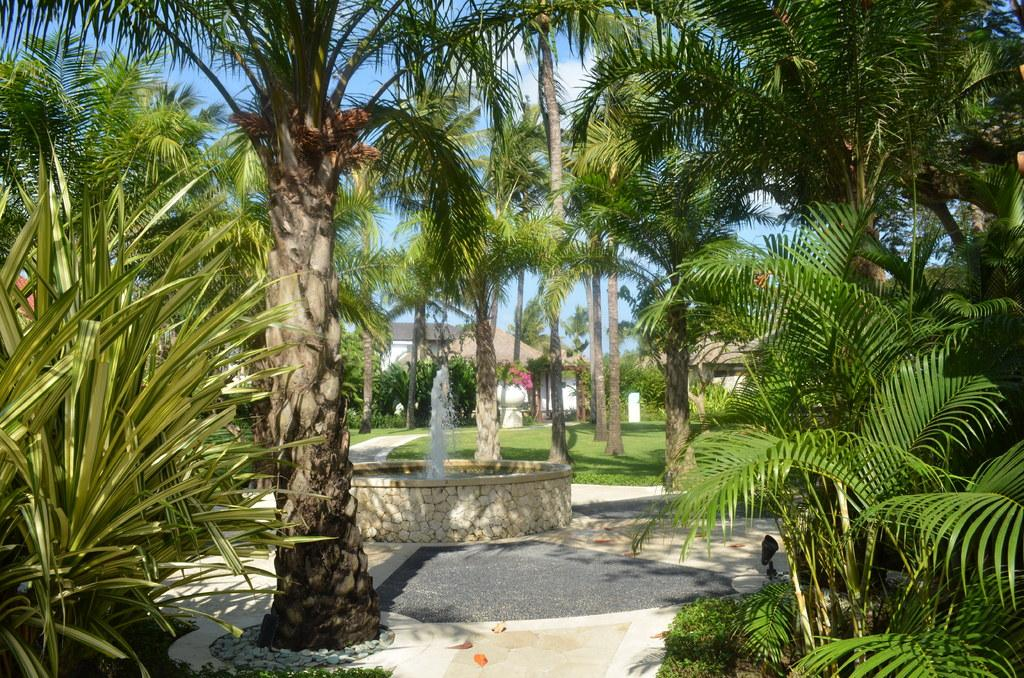What type of vegetation can be seen in the image? There are trees, grass, and plants in the image. What type of structures are visible in the image? There are houses in the image. What can be seen in the background of the image? There are clouds and the sky visible in the background of the image. How many men are asking questions about their memory in the image? There are no men or questions about memory present in the image. 